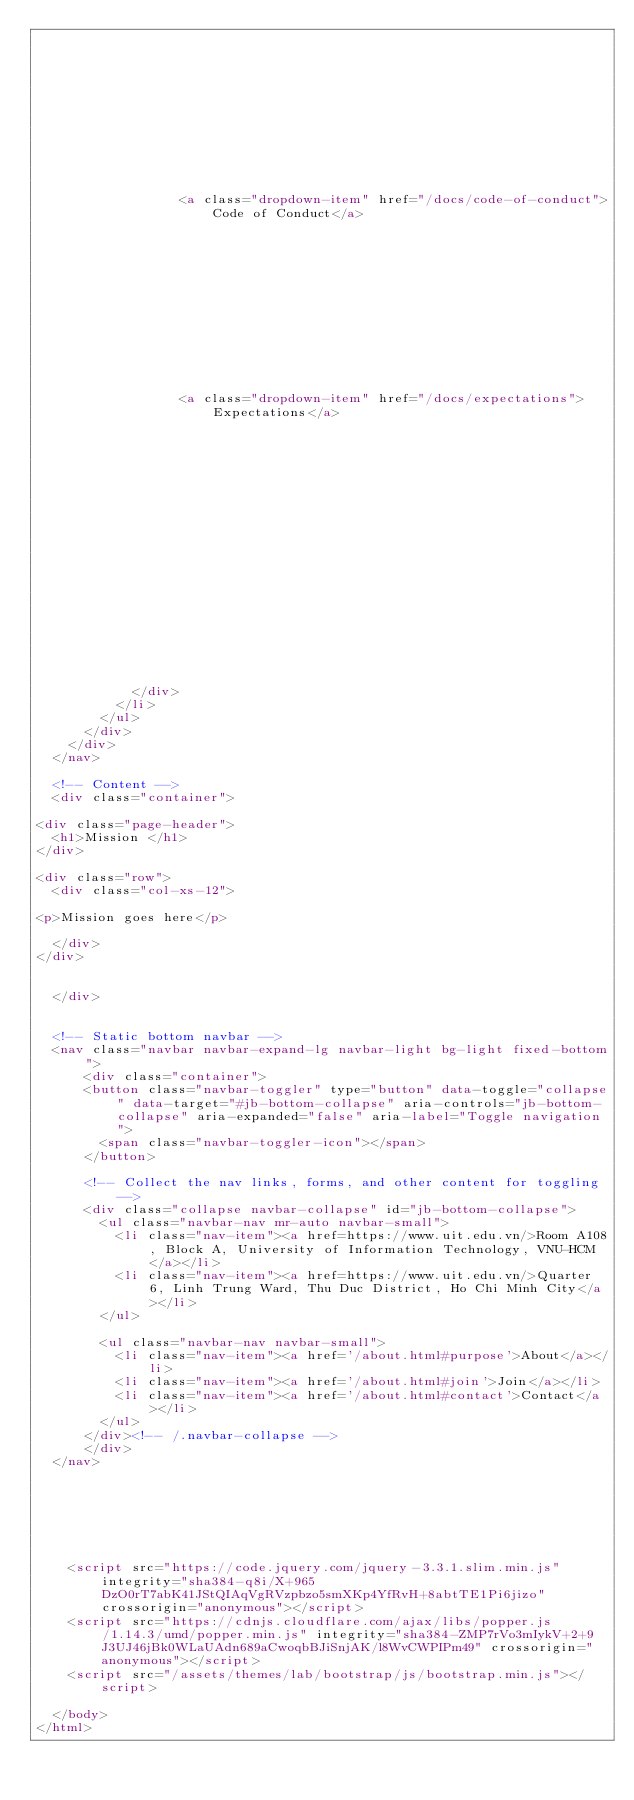<code> <loc_0><loc_0><loc_500><loc_500><_HTML_>      	
      
    
  
    
      
    
  
    
      	
      	
				  
				  <a class="dropdown-item" href="/docs/code-of-conduct">Code of Conduct</a>
				  
				
      
    
  
    
      
    
  
    
      	
      	
				  
				  <a class="dropdown-item" href="/docs/expectations">Expectations</a>
				  
				
      
    
  
    
      
    
  
    
      
    
  
    
      
    
  



            </div>
          </li>
        </ul>
      </div>
    </div>
  </nav>

  <!-- Content -->
  <div class="container">
    
<div class="page-header">
  <h1>Mission </h1>
</div>

<div class="row">
  <div class="col-xs-12">
    
<p>Mission goes here</p>

  </div>
</div>


  </div>


  <!-- Static bottom navbar -->
  <nav class="navbar navbar-expand-lg navbar-light bg-light fixed-bottom">
      <div class="container">
      <button class="navbar-toggler" type="button" data-toggle="collapse" data-target="#jb-bottom-collapse" aria-controls="jb-bottom-collapse" aria-expanded="false" aria-label="Toggle navigation">
        <span class="navbar-toggler-icon"></span>
      </button>
      
      <!-- Collect the nav links, forms, and other content for toggling -->
      <div class="collapse navbar-collapse" id="jb-bottom-collapse">
        <ul class="navbar-nav mr-auto navbar-small"> 
          <li class="nav-item"><a href=https://www.uit.edu.vn/>Room A108, Block A, University of Information Technology, VNU-HCM</a></li>
          <li class="nav-item"><a href=https://www.uit.edu.vn/>Quarter 6, Linh Trung Ward, Thu Duc District, Ho Chi Minh City</a></li>
        </ul>
        
        <ul class="navbar-nav navbar-small">
          <li class="nav-item"><a href='/about.html#purpose'>About</a></li>
          <li class="nav-item"><a href='/about.html#join'>Join</a></li>
          <li class="nav-item"><a href='/about.html#contact'>Contact</a></li>
        </ul>
      </div><!-- /.navbar-collapse -->
      </div>
  </nav>



    



    <script src="https://code.jquery.com/jquery-3.3.1.slim.min.js" integrity="sha384-q8i/X+965DzO0rT7abK41JStQIAqVgRVzpbzo5smXKp4YfRvH+8abtTE1Pi6jizo" crossorigin="anonymous"></script>
    <script src="https://cdnjs.cloudflare.com/ajax/libs/popper.js/1.14.3/umd/popper.min.js" integrity="sha384-ZMP7rVo3mIykV+2+9J3UJ46jBk0WLaUAdn689aCwoqbBJiSnjAK/l8WvCWPIPm49" crossorigin="anonymous"></script>
    <script src="/assets/themes/lab/bootstrap/js/bootstrap.min.js"></script>

  </body>
</html>

</code> 